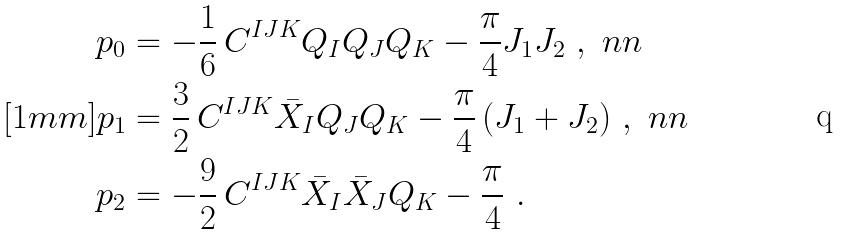Convert formula to latex. <formula><loc_0><loc_0><loc_500><loc_500>p _ { 0 } & = - \frac { 1 } { 6 } \, C ^ { I J K } Q _ { I } Q _ { J } Q _ { K } - \frac { \pi } { 4 } J _ { 1 } J _ { 2 } \ , \ n n \\ [ 1 m m ] p _ { 1 } & = \frac { 3 } { 2 } \, C ^ { I J K } \bar { X } _ { I } Q _ { J } Q _ { K } - \frac { \pi } { 4 } \, ( J _ { 1 } + J _ { 2 } ) \ , \ n n \\ p _ { 2 } & = - \frac { 9 } { 2 } \, C ^ { I J K } \bar { X } _ { I } \bar { X } _ { J } Q _ { K } - \frac { \pi } { 4 } \ .</formula> 